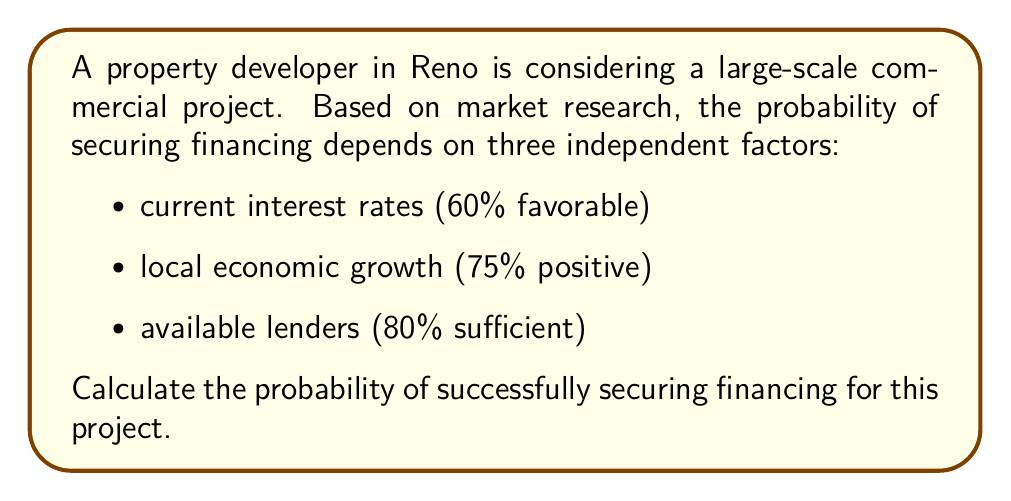Solve this math problem. To solve this problem, we'll use the multiplication rule of probability for independent events. The probability of all three favorable conditions occurring simultaneously is the product of their individual probabilities.

Let's define our events:
A: Favorable interest rates (P(A) = 0.60)
B: Positive local economic growth (P(B) = 0.75)
C: Sufficient available lenders (P(C) = 0.80)

The probability of securing financing is the probability of all these events occurring together:

P(securing financing) = P(A ∩ B ∩ C)

Since the events are independent:

P(A ∩ B ∩ C) = P(A) × P(B) × P(C)

Now, let's calculate:

$$\begin{align}
P(\text{securing financing}) &= 0.60 \times 0.75 \times 0.80 \\
&= 0.36
\end{align}$$

Therefore, the probability of successfully securing financing for this large-scale commercial project in Reno is 0.36 or 36%.
Answer: 0.36 or 36% 